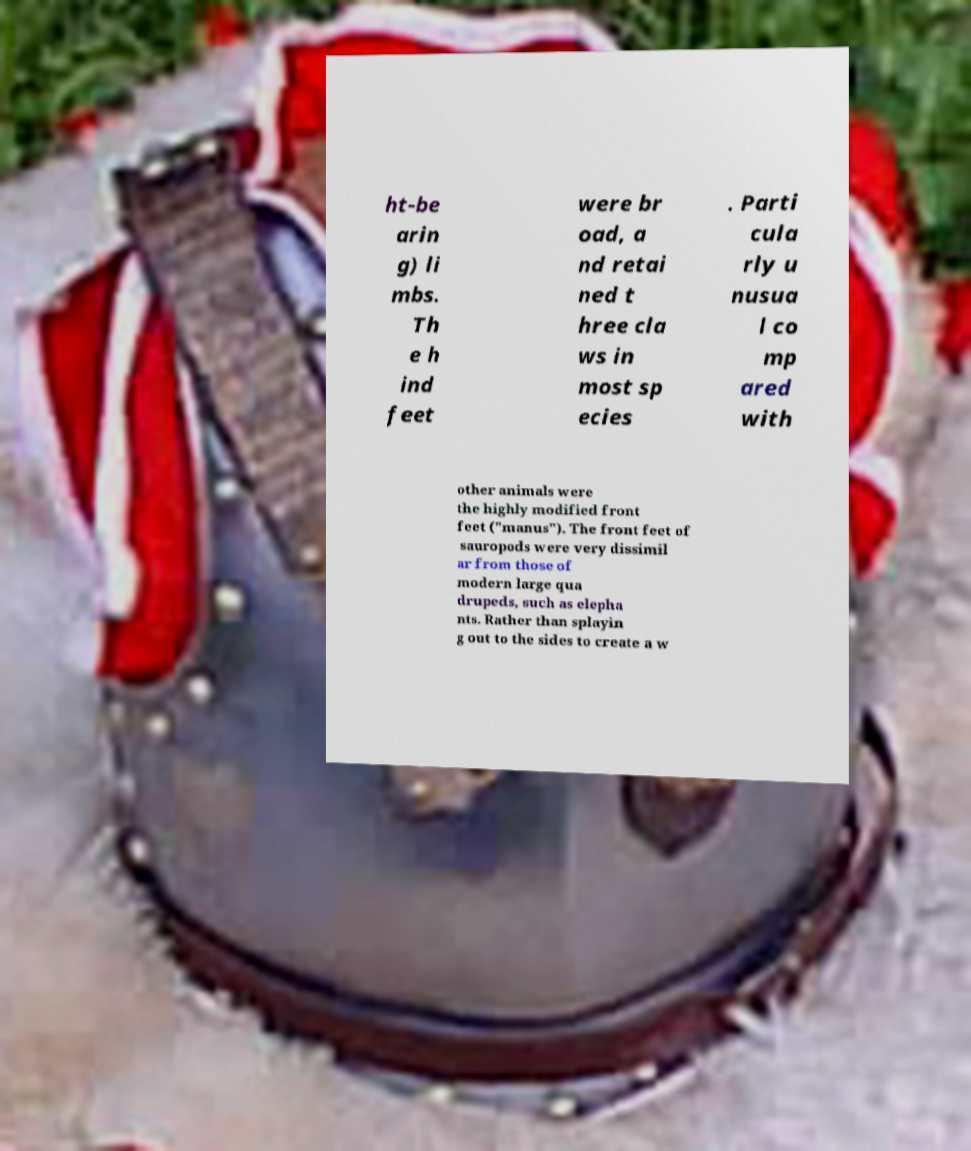Can you accurately transcribe the text from the provided image for me? ht-be arin g) li mbs. Th e h ind feet were br oad, a nd retai ned t hree cla ws in most sp ecies . Parti cula rly u nusua l co mp ared with other animals were the highly modified front feet ("manus"). The front feet of sauropods were very dissimil ar from those of modern large qua drupeds, such as elepha nts. Rather than splayin g out to the sides to create a w 